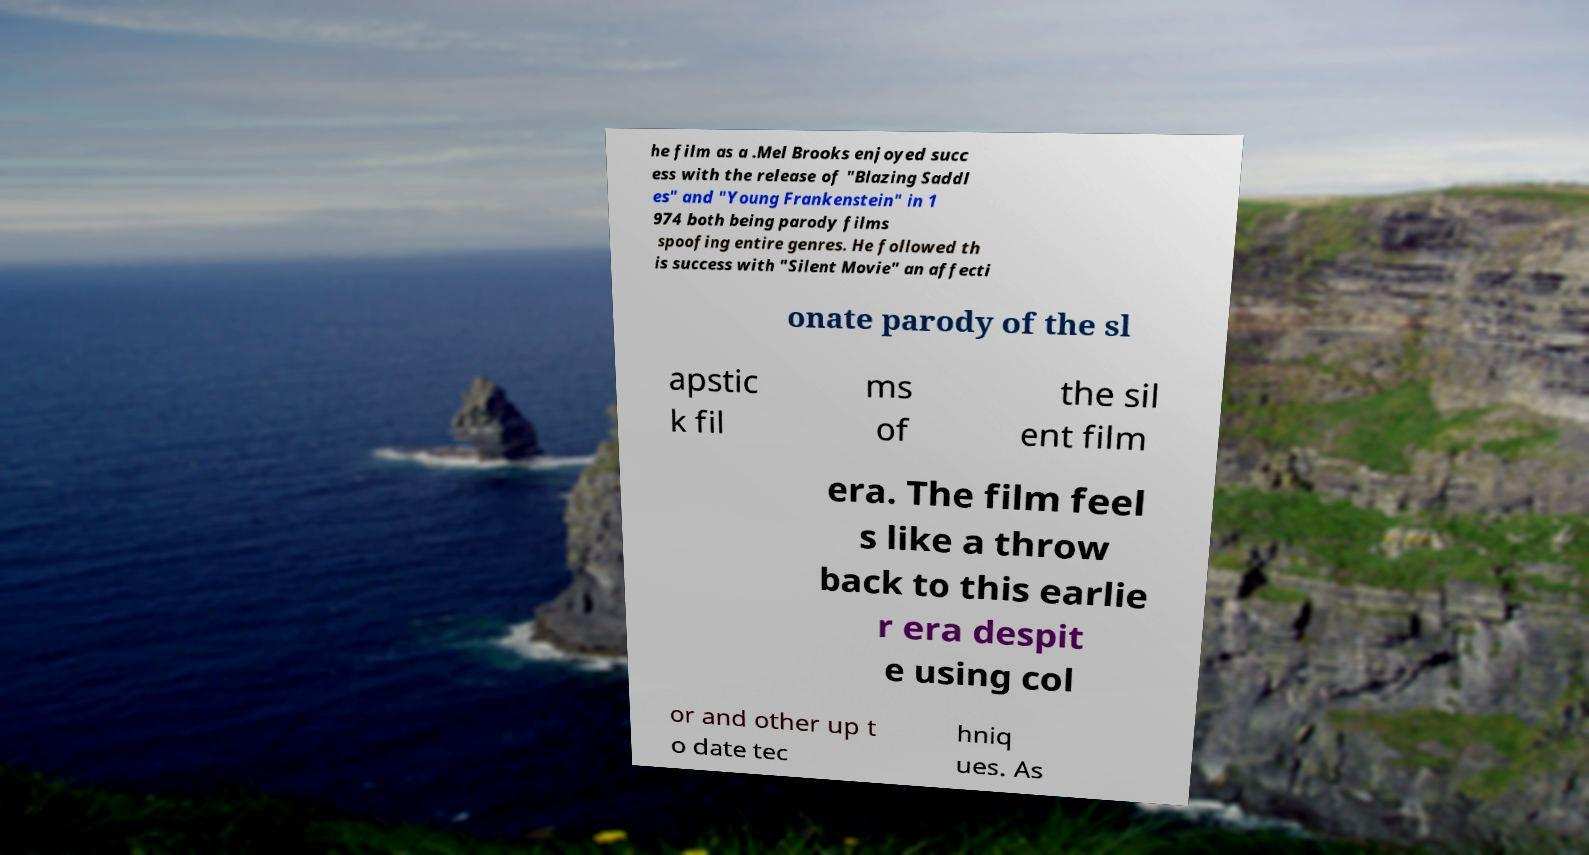Could you assist in decoding the text presented in this image and type it out clearly? he film as a .Mel Brooks enjoyed succ ess with the release of "Blazing Saddl es" and "Young Frankenstein" in 1 974 both being parody films spoofing entire genres. He followed th is success with "Silent Movie" an affecti onate parody of the sl apstic k fil ms of the sil ent film era. The film feel s like a throw back to this earlie r era despit e using col or and other up t o date tec hniq ues. As 